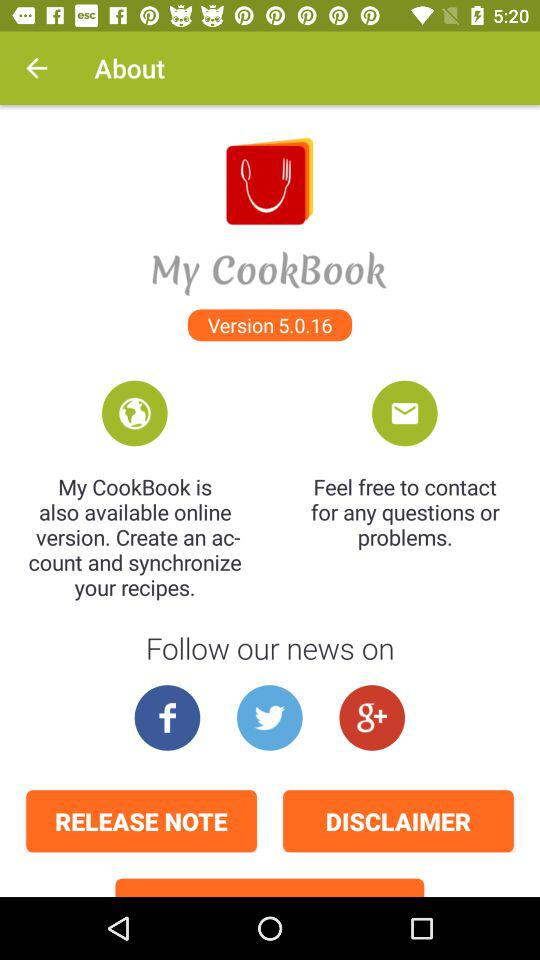What is the version of "My CookBook"? The version is 5.0.16. 